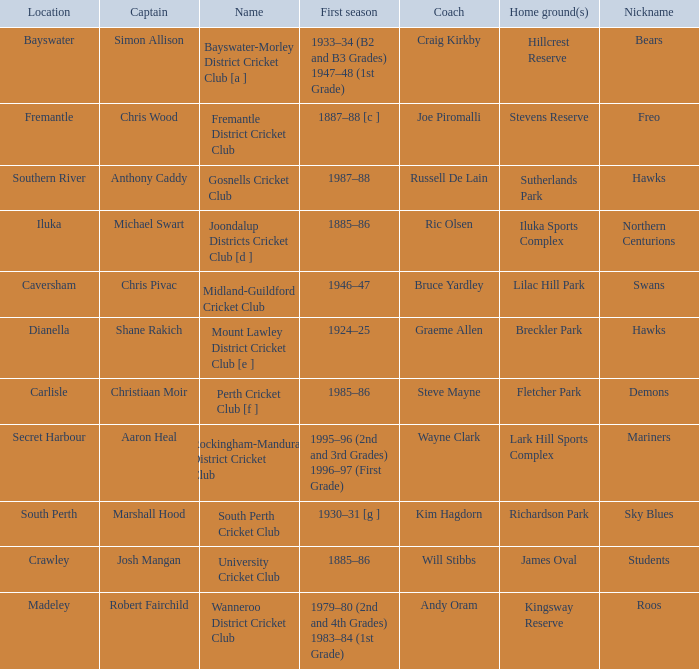What is the location for the club with the nickname the bears? Bayswater. 